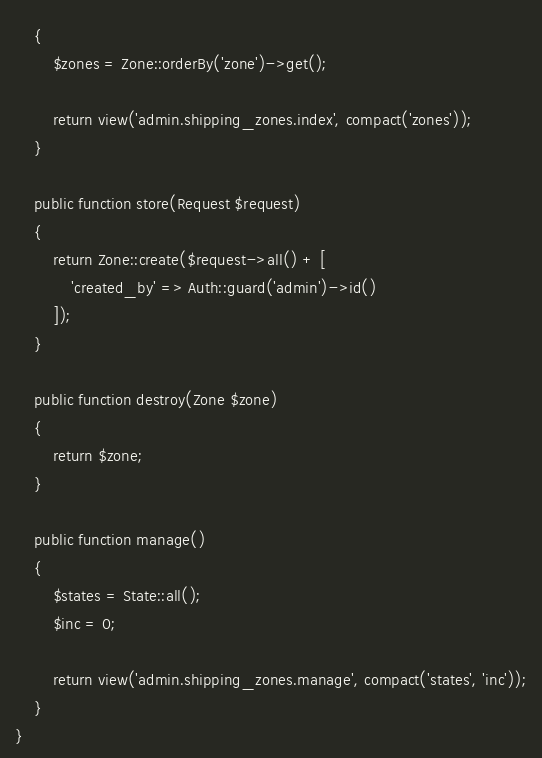Convert code to text. <code><loc_0><loc_0><loc_500><loc_500><_PHP_>    {
        $zones = Zone::orderBy('zone')->get();

        return view('admin.shipping_zones.index', compact('zones'));
    }

    public function store(Request $request)
    {
        return Zone::create($request->all() + [
            'created_by' => Auth::guard('admin')->id()
        ]);
    }

    public function destroy(Zone $zone)
    {
        return $zone;
    }
    
    public function manage()
    {
        $states = State::all();
        $inc = 0;

        return view('admin.shipping_zones.manage', compact('states', 'inc'));
    }
}
</code> 